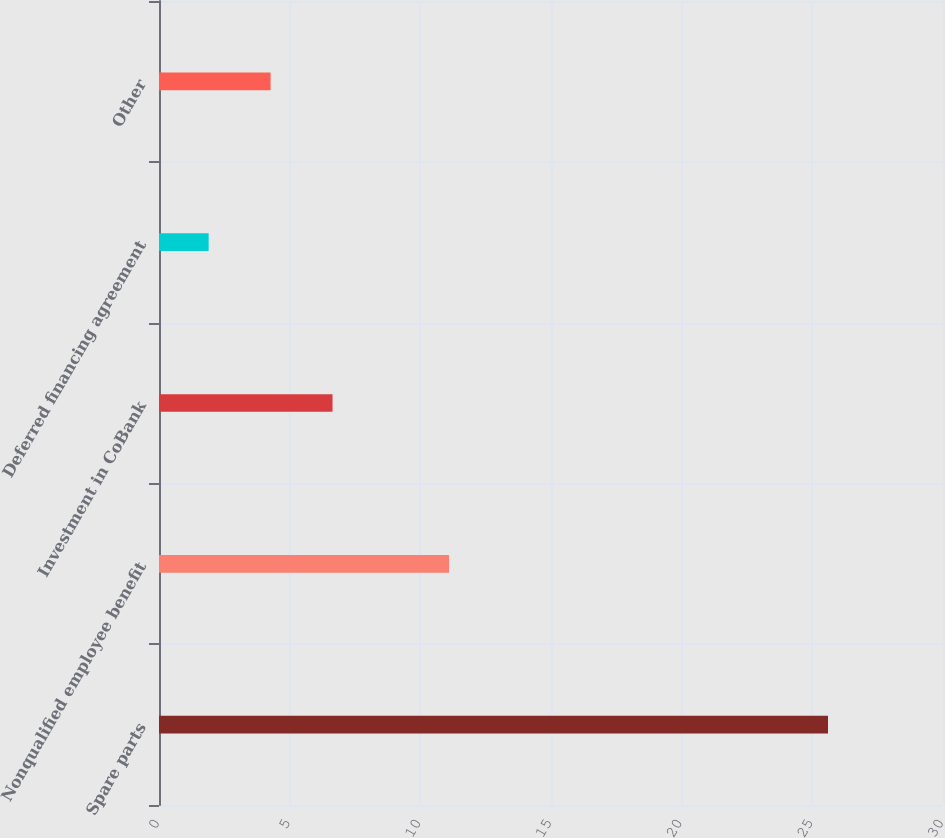Convert chart to OTSL. <chart><loc_0><loc_0><loc_500><loc_500><bar_chart><fcel>Spare parts<fcel>Nonqualified employee benefit<fcel>Investment in CoBank<fcel>Deferred financing agreement<fcel>Other<nl><fcel>25.6<fcel>11.1<fcel>6.64<fcel>1.9<fcel>4.27<nl></chart> 